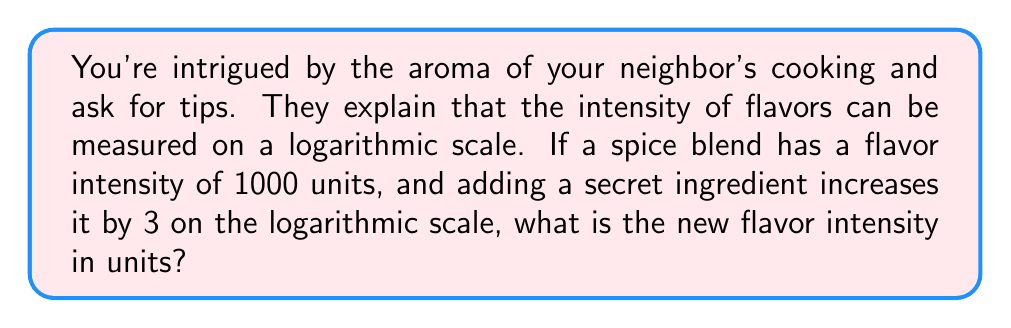Help me with this question. Let's approach this step-by-step:

1) The logarithmic scale for flavor intensity is typically based on powers of 10. An increase of 1 on this scale represents a 10-fold increase in intensity.

2) The initial flavor intensity is 1000 units. Let's express this in logarithmic form:

   $\log_{10}(1000) = 3$

3) The flavor intensity increases by 3 on the logarithmic scale. This means we add 3 to our initial logarithmic value:

   $3 + 3 = 6$

4) Now, we need to convert this back to linear units. We can do this by calculating:

   $10^6$

5) Let's evaluate this:

   $10^6 = 1,000,000$

Therefore, the new flavor intensity is 1,000,000 units.

To verify:
$\log_{10}(1,000,000) = 6$, which is indeed 3 more than our initial $\log_{10}(1000) = 3$
Answer: 1,000,000 units 